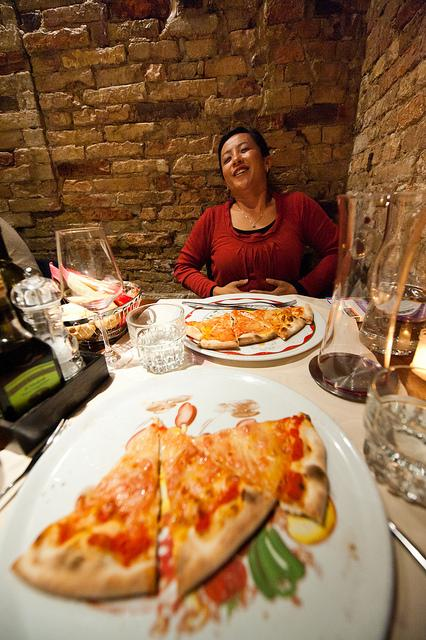What type of food is served here? pizza 